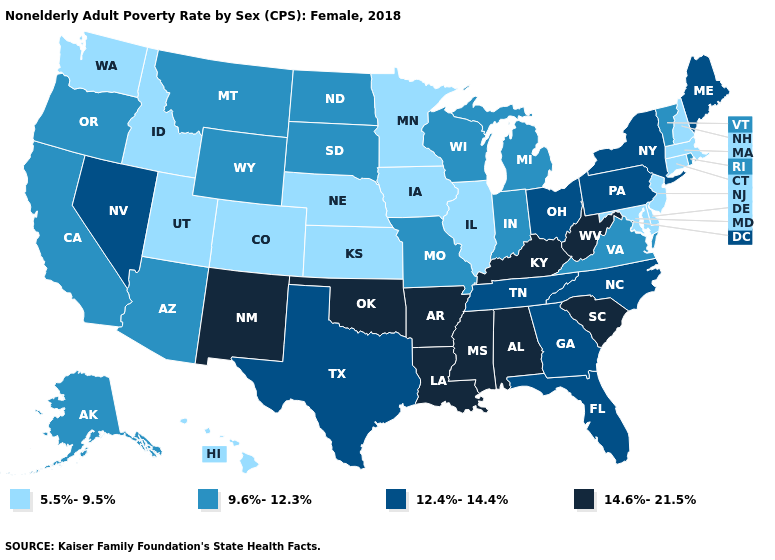Does Washington have a lower value than Nebraska?
Answer briefly. No. What is the value of North Carolina?
Keep it brief. 12.4%-14.4%. What is the value of Illinois?
Quick response, please. 5.5%-9.5%. Name the states that have a value in the range 5.5%-9.5%?
Short answer required. Colorado, Connecticut, Delaware, Hawaii, Idaho, Illinois, Iowa, Kansas, Maryland, Massachusetts, Minnesota, Nebraska, New Hampshire, New Jersey, Utah, Washington. What is the value of Delaware?
Give a very brief answer. 5.5%-9.5%. Does New Hampshire have the lowest value in the Northeast?
Quick response, please. Yes. How many symbols are there in the legend?
Short answer required. 4. Which states hav the highest value in the Northeast?
Quick response, please. Maine, New York, Pennsylvania. How many symbols are there in the legend?
Keep it brief. 4. Among the states that border North Carolina , does South Carolina have the highest value?
Keep it brief. Yes. Does Massachusetts have the lowest value in the Northeast?
Keep it brief. Yes. What is the value of Arkansas?
Be succinct. 14.6%-21.5%. Does New York have the highest value in the Northeast?
Give a very brief answer. Yes. What is the lowest value in the Northeast?
Keep it brief. 5.5%-9.5%. What is the value of Texas?
Keep it brief. 12.4%-14.4%. 